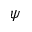Convert formula to latex. <formula><loc_0><loc_0><loc_500><loc_500>\psi</formula> 